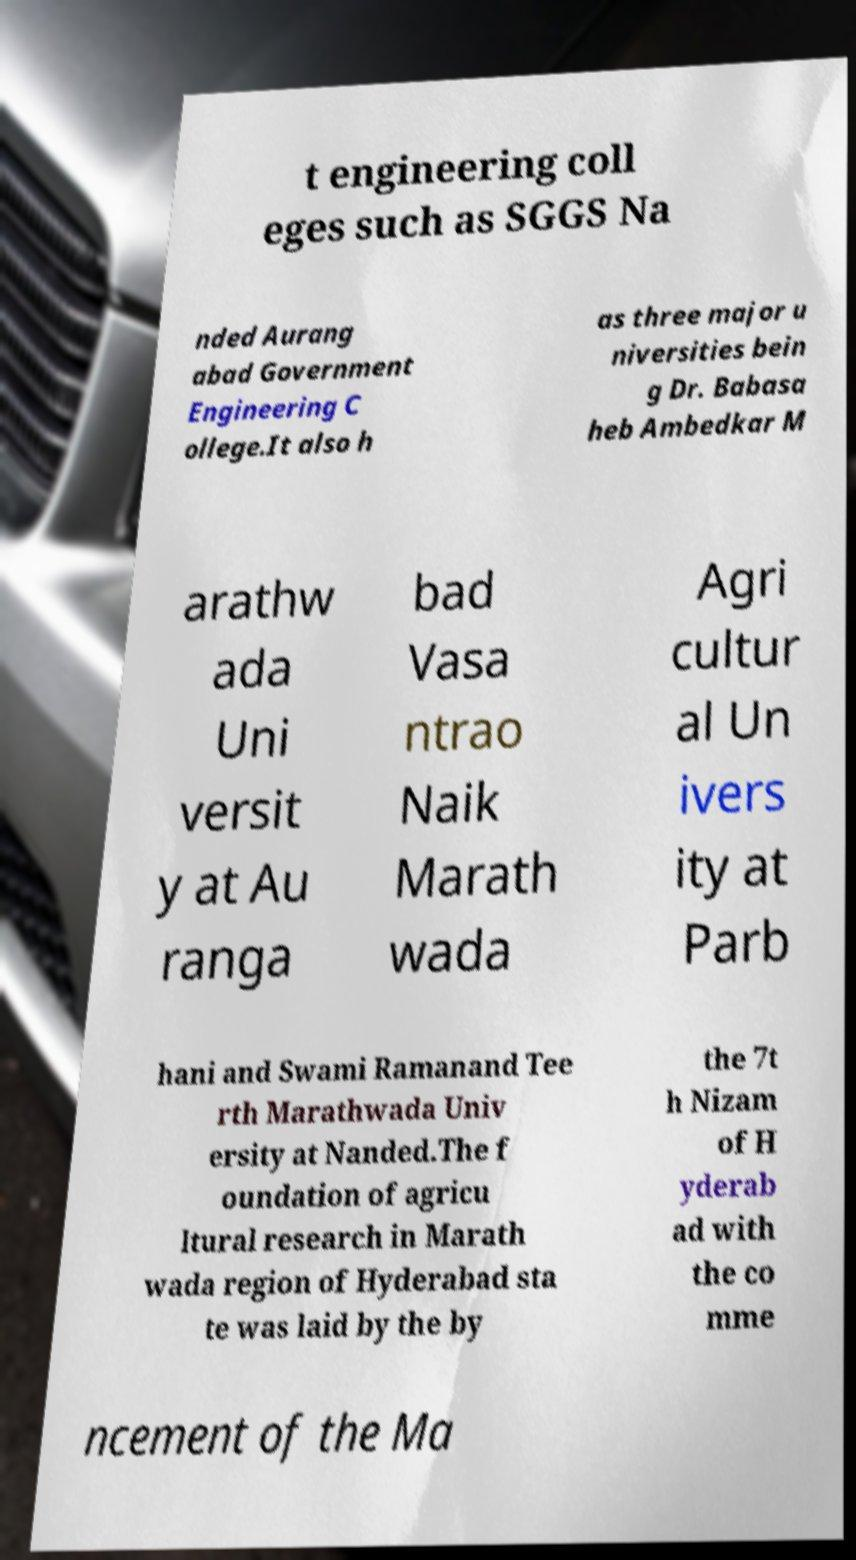Please identify and transcribe the text found in this image. t engineering coll eges such as SGGS Na nded Aurang abad Government Engineering C ollege.It also h as three major u niversities bein g Dr. Babasa heb Ambedkar M arathw ada Uni versit y at Au ranga bad Vasa ntrao Naik Marath wada Agri cultur al Un ivers ity at Parb hani and Swami Ramanand Tee rth Marathwada Univ ersity at Nanded.The f oundation of agricu ltural research in Marath wada region of Hyderabad sta te was laid by the by the 7t h Nizam of H yderab ad with the co mme ncement of the Ma 